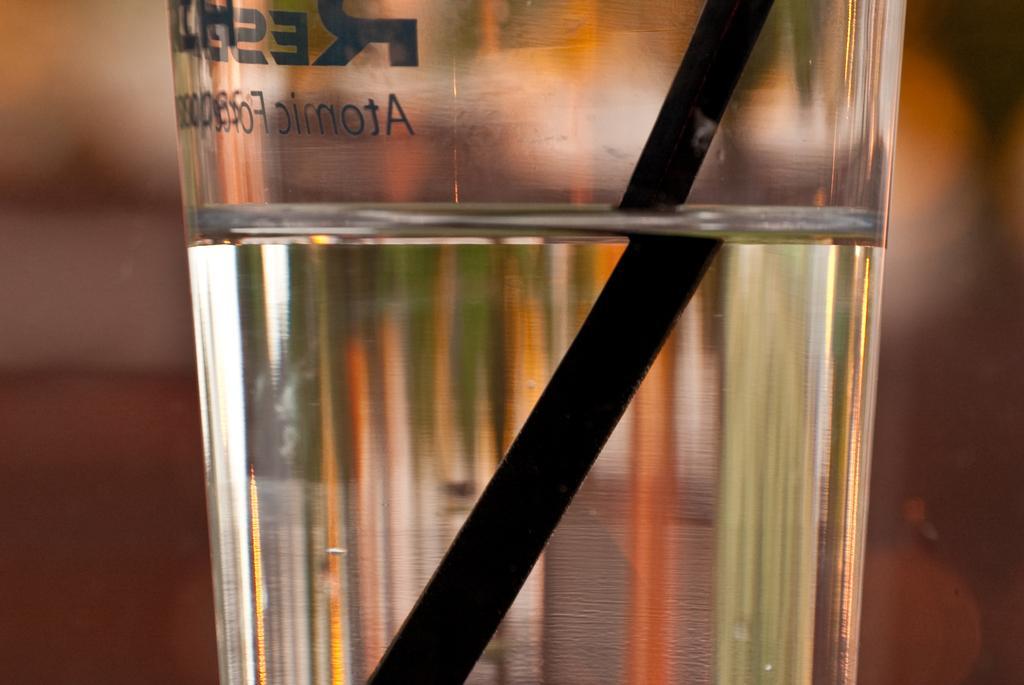Describe this image in one or two sentences. This picture shows a glass with water and we see a straw in it. 